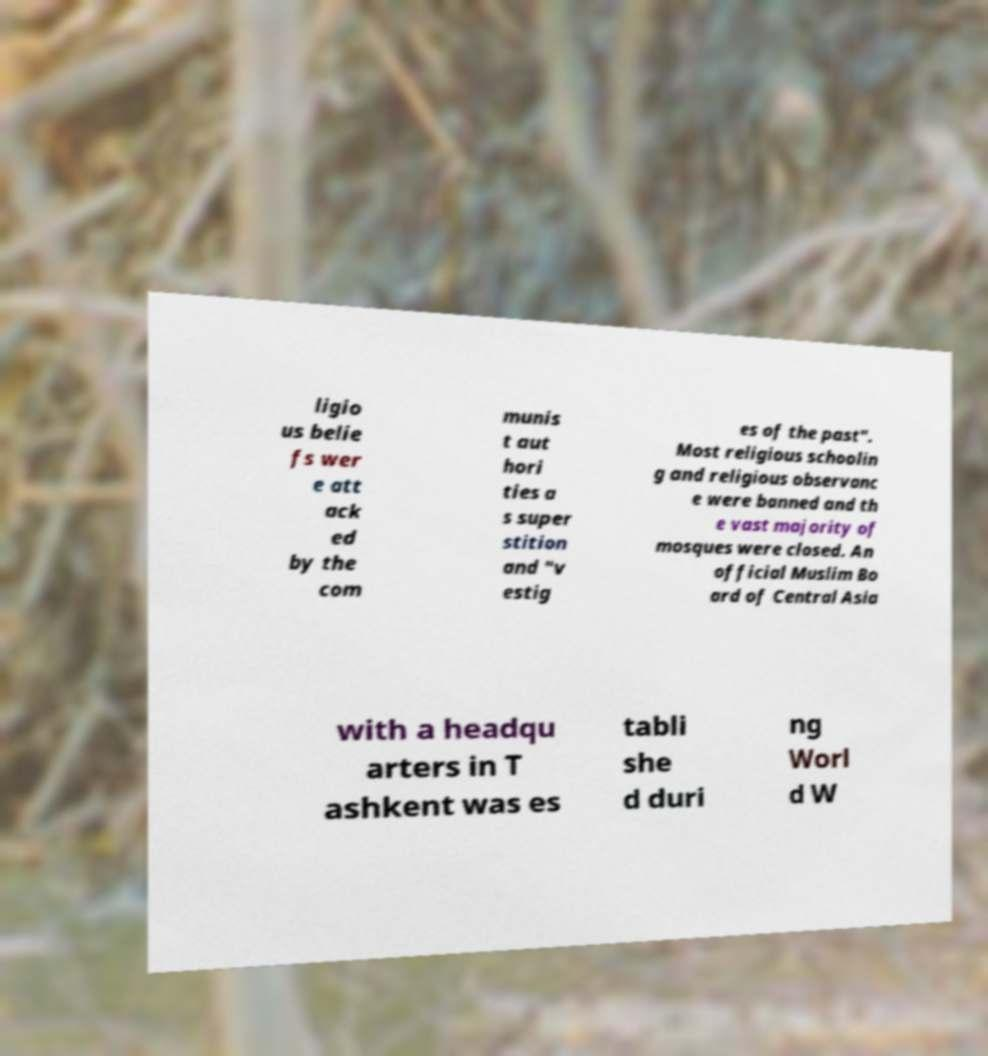Please read and relay the text visible in this image. What does it say? ligio us belie fs wer e att ack ed by the com munis t aut hori ties a s super stition and "v estig es of the past". Most religious schoolin g and religious observanc e were banned and th e vast majority of mosques were closed. An official Muslim Bo ard of Central Asia with a headqu arters in T ashkent was es tabli she d duri ng Worl d W 